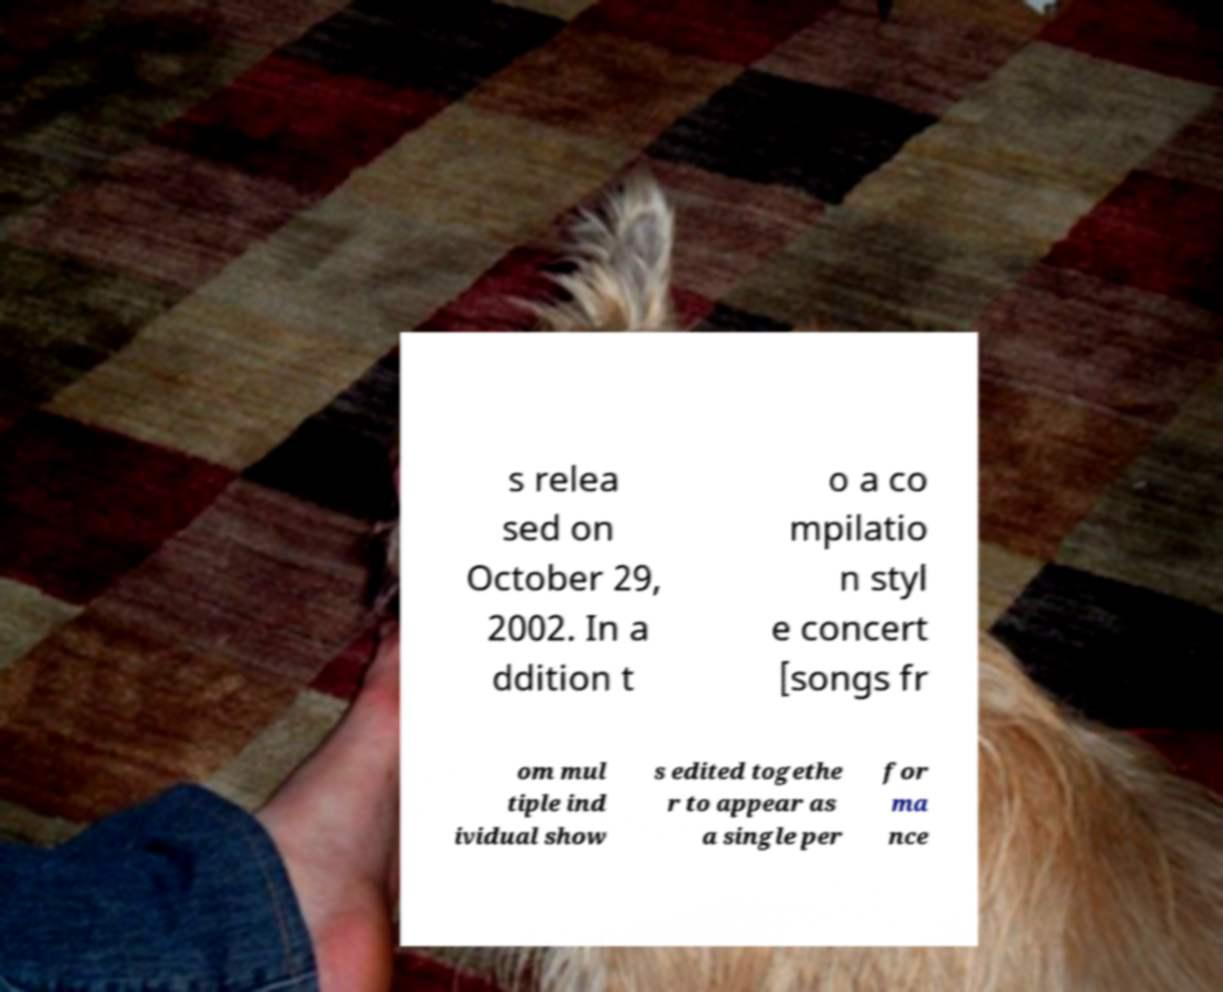Could you extract and type out the text from this image? s relea sed on October 29, 2002. In a ddition t o a co mpilatio n styl e concert [songs fr om mul tiple ind ividual show s edited togethe r to appear as a single per for ma nce 